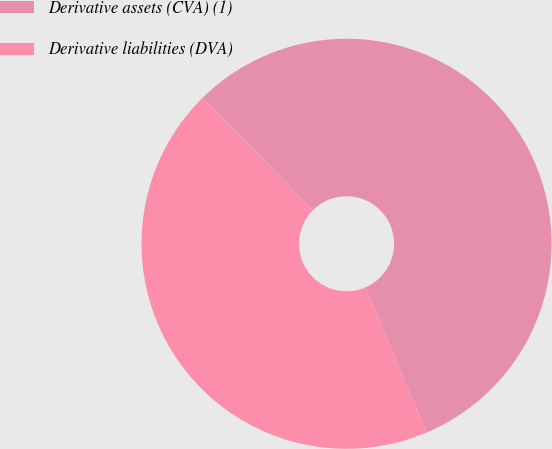Convert chart. <chart><loc_0><loc_0><loc_500><loc_500><pie_chart><fcel>Derivative assets (CVA) (1)<fcel>Derivative liabilities (DVA)<nl><fcel>56.01%<fcel>43.99%<nl></chart> 